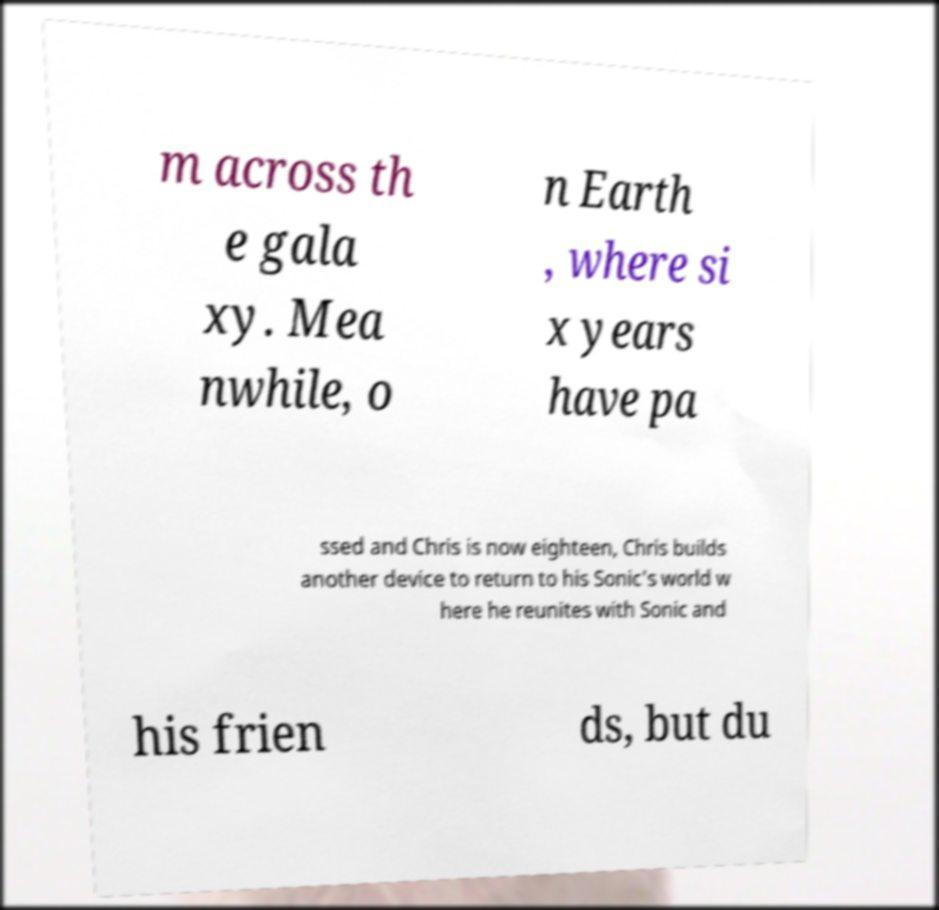There's text embedded in this image that I need extracted. Can you transcribe it verbatim? m across th e gala xy. Mea nwhile, o n Earth , where si x years have pa ssed and Chris is now eighteen, Chris builds another device to return to his Sonic's world w here he reunites with Sonic and his frien ds, but du 